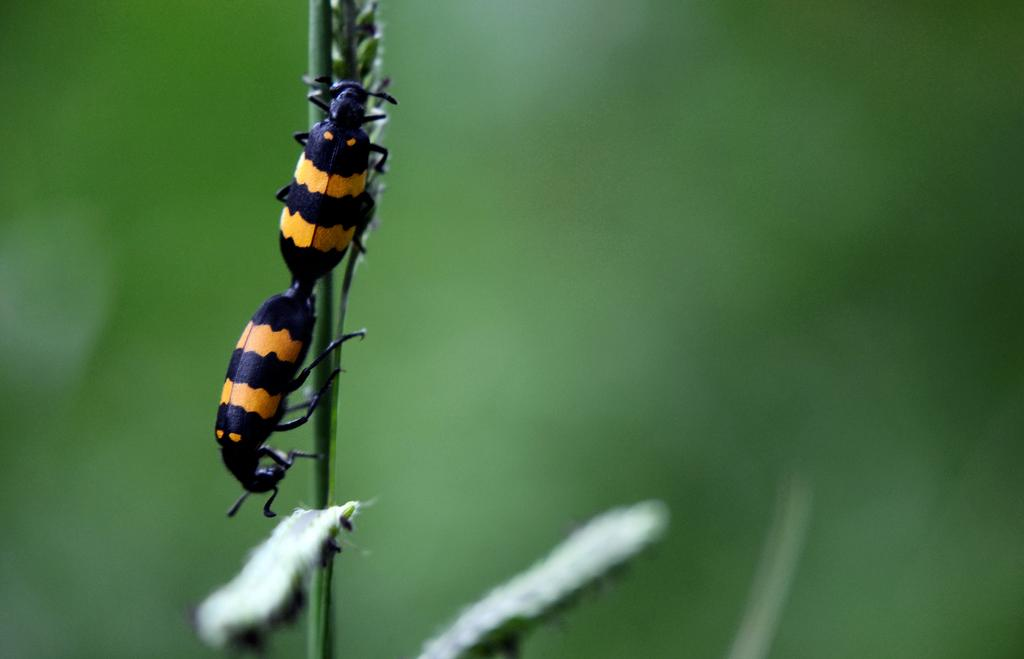What type of creature can be seen in the image? There is an insect in the image. Can you describe the background of the image? The background of the image is blurry. Is the insect swimming in the image? There is no indication that the insect is swimming in the image, as it is not in a body of water. 